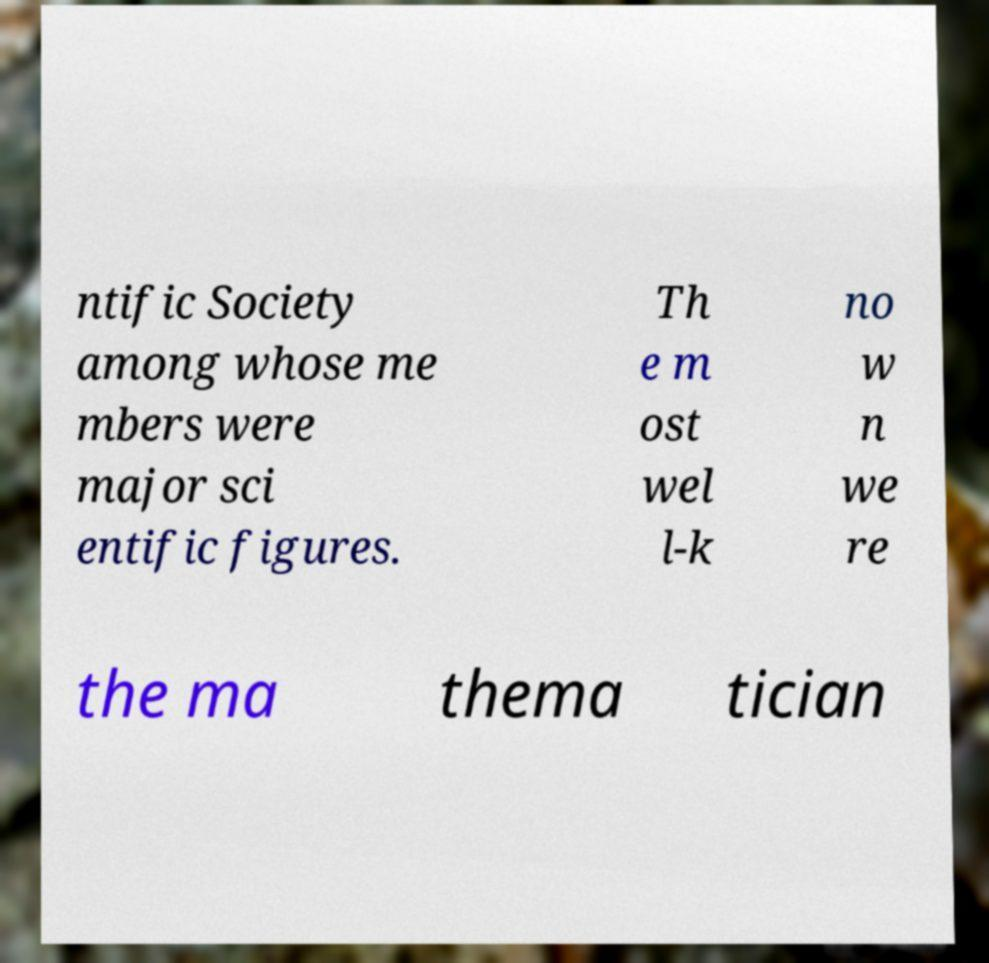Can you read and provide the text displayed in the image?This photo seems to have some interesting text. Can you extract and type it out for me? ntific Society among whose me mbers were major sci entific figures. Th e m ost wel l-k no w n we re the ma thema tician 